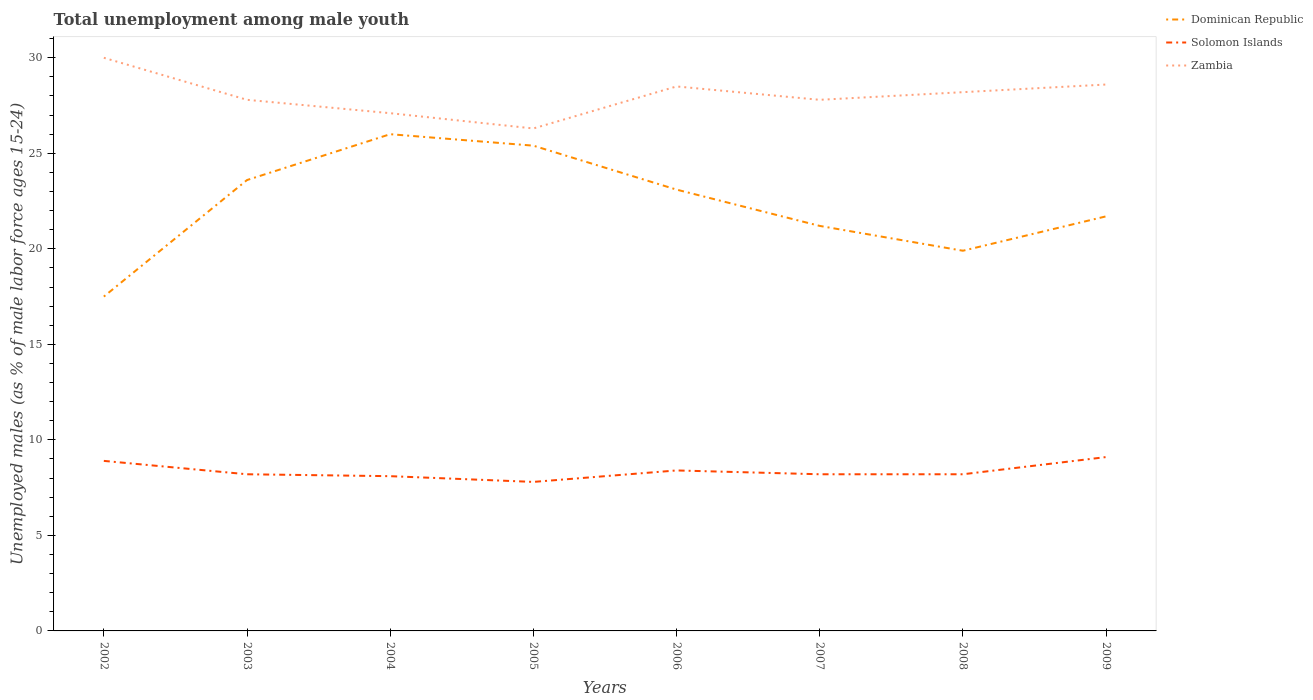How many different coloured lines are there?
Provide a short and direct response. 3. Does the line corresponding to Zambia intersect with the line corresponding to Solomon Islands?
Your answer should be very brief. No. Is the number of lines equal to the number of legend labels?
Give a very brief answer. Yes. Across all years, what is the maximum percentage of unemployed males in in Solomon Islands?
Give a very brief answer. 7.8. In which year was the percentage of unemployed males in in Zambia maximum?
Give a very brief answer. 2005. What is the total percentage of unemployed males in in Solomon Islands in the graph?
Make the answer very short. -0.4. What is the difference between the highest and the second highest percentage of unemployed males in in Dominican Republic?
Your answer should be very brief. 8.5. What is the difference between the highest and the lowest percentage of unemployed males in in Solomon Islands?
Provide a short and direct response. 3. How many lines are there?
Your response must be concise. 3. How many years are there in the graph?
Offer a terse response. 8. What is the difference between two consecutive major ticks on the Y-axis?
Your answer should be compact. 5. Are the values on the major ticks of Y-axis written in scientific E-notation?
Offer a terse response. No. Does the graph contain grids?
Give a very brief answer. No. What is the title of the graph?
Provide a short and direct response. Total unemployment among male youth. What is the label or title of the Y-axis?
Offer a terse response. Unemployed males (as % of male labor force ages 15-24). What is the Unemployed males (as % of male labor force ages 15-24) in Solomon Islands in 2002?
Your response must be concise. 8.9. What is the Unemployed males (as % of male labor force ages 15-24) of Zambia in 2002?
Offer a very short reply. 30. What is the Unemployed males (as % of male labor force ages 15-24) of Dominican Republic in 2003?
Make the answer very short. 23.6. What is the Unemployed males (as % of male labor force ages 15-24) of Solomon Islands in 2003?
Your response must be concise. 8.2. What is the Unemployed males (as % of male labor force ages 15-24) in Zambia in 2003?
Offer a very short reply. 27.8. What is the Unemployed males (as % of male labor force ages 15-24) of Dominican Republic in 2004?
Provide a succinct answer. 26. What is the Unemployed males (as % of male labor force ages 15-24) in Solomon Islands in 2004?
Your response must be concise. 8.1. What is the Unemployed males (as % of male labor force ages 15-24) in Zambia in 2004?
Give a very brief answer. 27.1. What is the Unemployed males (as % of male labor force ages 15-24) of Dominican Republic in 2005?
Ensure brevity in your answer.  25.4. What is the Unemployed males (as % of male labor force ages 15-24) of Solomon Islands in 2005?
Your answer should be very brief. 7.8. What is the Unemployed males (as % of male labor force ages 15-24) of Zambia in 2005?
Ensure brevity in your answer.  26.3. What is the Unemployed males (as % of male labor force ages 15-24) in Dominican Republic in 2006?
Provide a short and direct response. 23.1. What is the Unemployed males (as % of male labor force ages 15-24) in Solomon Islands in 2006?
Your answer should be very brief. 8.4. What is the Unemployed males (as % of male labor force ages 15-24) in Dominican Republic in 2007?
Give a very brief answer. 21.2. What is the Unemployed males (as % of male labor force ages 15-24) of Solomon Islands in 2007?
Your answer should be very brief. 8.2. What is the Unemployed males (as % of male labor force ages 15-24) of Zambia in 2007?
Keep it short and to the point. 27.8. What is the Unemployed males (as % of male labor force ages 15-24) of Dominican Republic in 2008?
Offer a very short reply. 19.9. What is the Unemployed males (as % of male labor force ages 15-24) in Solomon Islands in 2008?
Keep it short and to the point. 8.2. What is the Unemployed males (as % of male labor force ages 15-24) of Zambia in 2008?
Provide a short and direct response. 28.2. What is the Unemployed males (as % of male labor force ages 15-24) in Dominican Republic in 2009?
Your answer should be compact. 21.7. What is the Unemployed males (as % of male labor force ages 15-24) of Solomon Islands in 2009?
Offer a terse response. 9.1. What is the Unemployed males (as % of male labor force ages 15-24) of Zambia in 2009?
Keep it short and to the point. 28.6. Across all years, what is the maximum Unemployed males (as % of male labor force ages 15-24) of Dominican Republic?
Make the answer very short. 26. Across all years, what is the maximum Unemployed males (as % of male labor force ages 15-24) of Solomon Islands?
Offer a very short reply. 9.1. Across all years, what is the maximum Unemployed males (as % of male labor force ages 15-24) of Zambia?
Offer a very short reply. 30. Across all years, what is the minimum Unemployed males (as % of male labor force ages 15-24) in Dominican Republic?
Provide a short and direct response. 17.5. Across all years, what is the minimum Unemployed males (as % of male labor force ages 15-24) of Solomon Islands?
Your response must be concise. 7.8. Across all years, what is the minimum Unemployed males (as % of male labor force ages 15-24) of Zambia?
Your response must be concise. 26.3. What is the total Unemployed males (as % of male labor force ages 15-24) in Dominican Republic in the graph?
Provide a short and direct response. 178.4. What is the total Unemployed males (as % of male labor force ages 15-24) of Solomon Islands in the graph?
Your answer should be compact. 66.9. What is the total Unemployed males (as % of male labor force ages 15-24) in Zambia in the graph?
Give a very brief answer. 224.3. What is the difference between the Unemployed males (as % of male labor force ages 15-24) of Dominican Republic in 2002 and that in 2003?
Offer a terse response. -6.1. What is the difference between the Unemployed males (as % of male labor force ages 15-24) in Solomon Islands in 2002 and that in 2004?
Your answer should be compact. 0.8. What is the difference between the Unemployed males (as % of male labor force ages 15-24) in Zambia in 2002 and that in 2004?
Your answer should be compact. 2.9. What is the difference between the Unemployed males (as % of male labor force ages 15-24) in Dominican Republic in 2002 and that in 2005?
Keep it short and to the point. -7.9. What is the difference between the Unemployed males (as % of male labor force ages 15-24) of Dominican Republic in 2002 and that in 2006?
Provide a short and direct response. -5.6. What is the difference between the Unemployed males (as % of male labor force ages 15-24) of Zambia in 2002 and that in 2006?
Provide a short and direct response. 1.5. What is the difference between the Unemployed males (as % of male labor force ages 15-24) in Dominican Republic in 2002 and that in 2007?
Provide a short and direct response. -3.7. What is the difference between the Unemployed males (as % of male labor force ages 15-24) in Dominican Republic in 2002 and that in 2008?
Provide a succinct answer. -2.4. What is the difference between the Unemployed males (as % of male labor force ages 15-24) of Zambia in 2002 and that in 2008?
Make the answer very short. 1.8. What is the difference between the Unemployed males (as % of male labor force ages 15-24) of Dominican Republic in 2002 and that in 2009?
Your answer should be compact. -4.2. What is the difference between the Unemployed males (as % of male labor force ages 15-24) of Zambia in 2002 and that in 2009?
Your answer should be compact. 1.4. What is the difference between the Unemployed males (as % of male labor force ages 15-24) in Dominican Republic in 2003 and that in 2004?
Your answer should be compact. -2.4. What is the difference between the Unemployed males (as % of male labor force ages 15-24) of Solomon Islands in 2003 and that in 2004?
Offer a terse response. 0.1. What is the difference between the Unemployed males (as % of male labor force ages 15-24) of Zambia in 2003 and that in 2005?
Offer a terse response. 1.5. What is the difference between the Unemployed males (as % of male labor force ages 15-24) in Dominican Republic in 2003 and that in 2006?
Keep it short and to the point. 0.5. What is the difference between the Unemployed males (as % of male labor force ages 15-24) in Zambia in 2003 and that in 2006?
Provide a succinct answer. -0.7. What is the difference between the Unemployed males (as % of male labor force ages 15-24) of Solomon Islands in 2003 and that in 2007?
Provide a short and direct response. 0. What is the difference between the Unemployed males (as % of male labor force ages 15-24) in Solomon Islands in 2003 and that in 2008?
Your answer should be compact. 0. What is the difference between the Unemployed males (as % of male labor force ages 15-24) in Zambia in 2003 and that in 2009?
Keep it short and to the point. -0.8. What is the difference between the Unemployed males (as % of male labor force ages 15-24) in Solomon Islands in 2004 and that in 2005?
Offer a very short reply. 0.3. What is the difference between the Unemployed males (as % of male labor force ages 15-24) in Solomon Islands in 2004 and that in 2007?
Make the answer very short. -0.1. What is the difference between the Unemployed males (as % of male labor force ages 15-24) in Zambia in 2004 and that in 2007?
Offer a terse response. -0.7. What is the difference between the Unemployed males (as % of male labor force ages 15-24) in Zambia in 2004 and that in 2008?
Offer a very short reply. -1.1. What is the difference between the Unemployed males (as % of male labor force ages 15-24) of Solomon Islands in 2004 and that in 2009?
Keep it short and to the point. -1. What is the difference between the Unemployed males (as % of male labor force ages 15-24) in Dominican Republic in 2005 and that in 2006?
Give a very brief answer. 2.3. What is the difference between the Unemployed males (as % of male labor force ages 15-24) in Zambia in 2005 and that in 2006?
Offer a very short reply. -2.2. What is the difference between the Unemployed males (as % of male labor force ages 15-24) in Solomon Islands in 2005 and that in 2008?
Ensure brevity in your answer.  -0.4. What is the difference between the Unemployed males (as % of male labor force ages 15-24) in Zambia in 2005 and that in 2008?
Your answer should be compact. -1.9. What is the difference between the Unemployed males (as % of male labor force ages 15-24) in Dominican Republic in 2005 and that in 2009?
Your answer should be compact. 3.7. What is the difference between the Unemployed males (as % of male labor force ages 15-24) in Dominican Republic in 2006 and that in 2007?
Provide a succinct answer. 1.9. What is the difference between the Unemployed males (as % of male labor force ages 15-24) in Solomon Islands in 2006 and that in 2007?
Offer a terse response. 0.2. What is the difference between the Unemployed males (as % of male labor force ages 15-24) in Zambia in 2006 and that in 2007?
Provide a succinct answer. 0.7. What is the difference between the Unemployed males (as % of male labor force ages 15-24) of Solomon Islands in 2006 and that in 2008?
Your answer should be compact. 0.2. What is the difference between the Unemployed males (as % of male labor force ages 15-24) in Zambia in 2006 and that in 2009?
Your answer should be compact. -0.1. What is the difference between the Unemployed males (as % of male labor force ages 15-24) of Solomon Islands in 2007 and that in 2008?
Your answer should be very brief. 0. What is the difference between the Unemployed males (as % of male labor force ages 15-24) in Dominican Republic in 2008 and that in 2009?
Provide a short and direct response. -1.8. What is the difference between the Unemployed males (as % of male labor force ages 15-24) of Zambia in 2008 and that in 2009?
Keep it short and to the point. -0.4. What is the difference between the Unemployed males (as % of male labor force ages 15-24) of Dominican Republic in 2002 and the Unemployed males (as % of male labor force ages 15-24) of Zambia in 2003?
Ensure brevity in your answer.  -10.3. What is the difference between the Unemployed males (as % of male labor force ages 15-24) in Solomon Islands in 2002 and the Unemployed males (as % of male labor force ages 15-24) in Zambia in 2003?
Offer a very short reply. -18.9. What is the difference between the Unemployed males (as % of male labor force ages 15-24) of Solomon Islands in 2002 and the Unemployed males (as % of male labor force ages 15-24) of Zambia in 2004?
Your answer should be very brief. -18.2. What is the difference between the Unemployed males (as % of male labor force ages 15-24) of Dominican Republic in 2002 and the Unemployed males (as % of male labor force ages 15-24) of Zambia in 2005?
Provide a succinct answer. -8.8. What is the difference between the Unemployed males (as % of male labor force ages 15-24) in Solomon Islands in 2002 and the Unemployed males (as % of male labor force ages 15-24) in Zambia in 2005?
Offer a very short reply. -17.4. What is the difference between the Unemployed males (as % of male labor force ages 15-24) of Dominican Republic in 2002 and the Unemployed males (as % of male labor force ages 15-24) of Zambia in 2006?
Your answer should be compact. -11. What is the difference between the Unemployed males (as % of male labor force ages 15-24) of Solomon Islands in 2002 and the Unemployed males (as % of male labor force ages 15-24) of Zambia in 2006?
Provide a short and direct response. -19.6. What is the difference between the Unemployed males (as % of male labor force ages 15-24) of Dominican Republic in 2002 and the Unemployed males (as % of male labor force ages 15-24) of Zambia in 2007?
Give a very brief answer. -10.3. What is the difference between the Unemployed males (as % of male labor force ages 15-24) in Solomon Islands in 2002 and the Unemployed males (as % of male labor force ages 15-24) in Zambia in 2007?
Your answer should be very brief. -18.9. What is the difference between the Unemployed males (as % of male labor force ages 15-24) of Dominican Republic in 2002 and the Unemployed males (as % of male labor force ages 15-24) of Solomon Islands in 2008?
Offer a very short reply. 9.3. What is the difference between the Unemployed males (as % of male labor force ages 15-24) of Dominican Republic in 2002 and the Unemployed males (as % of male labor force ages 15-24) of Zambia in 2008?
Your answer should be very brief. -10.7. What is the difference between the Unemployed males (as % of male labor force ages 15-24) in Solomon Islands in 2002 and the Unemployed males (as % of male labor force ages 15-24) in Zambia in 2008?
Provide a short and direct response. -19.3. What is the difference between the Unemployed males (as % of male labor force ages 15-24) of Dominican Republic in 2002 and the Unemployed males (as % of male labor force ages 15-24) of Solomon Islands in 2009?
Make the answer very short. 8.4. What is the difference between the Unemployed males (as % of male labor force ages 15-24) of Dominican Republic in 2002 and the Unemployed males (as % of male labor force ages 15-24) of Zambia in 2009?
Ensure brevity in your answer.  -11.1. What is the difference between the Unemployed males (as % of male labor force ages 15-24) of Solomon Islands in 2002 and the Unemployed males (as % of male labor force ages 15-24) of Zambia in 2009?
Make the answer very short. -19.7. What is the difference between the Unemployed males (as % of male labor force ages 15-24) of Dominican Republic in 2003 and the Unemployed males (as % of male labor force ages 15-24) of Zambia in 2004?
Make the answer very short. -3.5. What is the difference between the Unemployed males (as % of male labor force ages 15-24) of Solomon Islands in 2003 and the Unemployed males (as % of male labor force ages 15-24) of Zambia in 2004?
Keep it short and to the point. -18.9. What is the difference between the Unemployed males (as % of male labor force ages 15-24) of Solomon Islands in 2003 and the Unemployed males (as % of male labor force ages 15-24) of Zambia in 2005?
Make the answer very short. -18.1. What is the difference between the Unemployed males (as % of male labor force ages 15-24) in Solomon Islands in 2003 and the Unemployed males (as % of male labor force ages 15-24) in Zambia in 2006?
Give a very brief answer. -20.3. What is the difference between the Unemployed males (as % of male labor force ages 15-24) in Dominican Republic in 2003 and the Unemployed males (as % of male labor force ages 15-24) in Zambia in 2007?
Make the answer very short. -4.2. What is the difference between the Unemployed males (as % of male labor force ages 15-24) of Solomon Islands in 2003 and the Unemployed males (as % of male labor force ages 15-24) of Zambia in 2007?
Offer a terse response. -19.6. What is the difference between the Unemployed males (as % of male labor force ages 15-24) in Solomon Islands in 2003 and the Unemployed males (as % of male labor force ages 15-24) in Zambia in 2008?
Make the answer very short. -20. What is the difference between the Unemployed males (as % of male labor force ages 15-24) of Solomon Islands in 2003 and the Unemployed males (as % of male labor force ages 15-24) of Zambia in 2009?
Your response must be concise. -20.4. What is the difference between the Unemployed males (as % of male labor force ages 15-24) of Solomon Islands in 2004 and the Unemployed males (as % of male labor force ages 15-24) of Zambia in 2005?
Your answer should be compact. -18.2. What is the difference between the Unemployed males (as % of male labor force ages 15-24) of Dominican Republic in 2004 and the Unemployed males (as % of male labor force ages 15-24) of Solomon Islands in 2006?
Keep it short and to the point. 17.6. What is the difference between the Unemployed males (as % of male labor force ages 15-24) in Dominican Republic in 2004 and the Unemployed males (as % of male labor force ages 15-24) in Zambia in 2006?
Give a very brief answer. -2.5. What is the difference between the Unemployed males (as % of male labor force ages 15-24) in Solomon Islands in 2004 and the Unemployed males (as % of male labor force ages 15-24) in Zambia in 2006?
Your response must be concise. -20.4. What is the difference between the Unemployed males (as % of male labor force ages 15-24) in Dominican Republic in 2004 and the Unemployed males (as % of male labor force ages 15-24) in Solomon Islands in 2007?
Your answer should be compact. 17.8. What is the difference between the Unemployed males (as % of male labor force ages 15-24) in Solomon Islands in 2004 and the Unemployed males (as % of male labor force ages 15-24) in Zambia in 2007?
Offer a very short reply. -19.7. What is the difference between the Unemployed males (as % of male labor force ages 15-24) in Solomon Islands in 2004 and the Unemployed males (as % of male labor force ages 15-24) in Zambia in 2008?
Your answer should be very brief. -20.1. What is the difference between the Unemployed males (as % of male labor force ages 15-24) in Dominican Republic in 2004 and the Unemployed males (as % of male labor force ages 15-24) in Zambia in 2009?
Give a very brief answer. -2.6. What is the difference between the Unemployed males (as % of male labor force ages 15-24) of Solomon Islands in 2004 and the Unemployed males (as % of male labor force ages 15-24) of Zambia in 2009?
Offer a terse response. -20.5. What is the difference between the Unemployed males (as % of male labor force ages 15-24) in Dominican Republic in 2005 and the Unemployed males (as % of male labor force ages 15-24) in Zambia in 2006?
Your response must be concise. -3.1. What is the difference between the Unemployed males (as % of male labor force ages 15-24) of Solomon Islands in 2005 and the Unemployed males (as % of male labor force ages 15-24) of Zambia in 2006?
Your answer should be very brief. -20.7. What is the difference between the Unemployed males (as % of male labor force ages 15-24) of Dominican Republic in 2005 and the Unemployed males (as % of male labor force ages 15-24) of Solomon Islands in 2007?
Ensure brevity in your answer.  17.2. What is the difference between the Unemployed males (as % of male labor force ages 15-24) in Dominican Republic in 2005 and the Unemployed males (as % of male labor force ages 15-24) in Zambia in 2007?
Ensure brevity in your answer.  -2.4. What is the difference between the Unemployed males (as % of male labor force ages 15-24) in Dominican Republic in 2005 and the Unemployed males (as % of male labor force ages 15-24) in Solomon Islands in 2008?
Provide a succinct answer. 17.2. What is the difference between the Unemployed males (as % of male labor force ages 15-24) in Dominican Republic in 2005 and the Unemployed males (as % of male labor force ages 15-24) in Zambia in 2008?
Give a very brief answer. -2.8. What is the difference between the Unemployed males (as % of male labor force ages 15-24) of Solomon Islands in 2005 and the Unemployed males (as % of male labor force ages 15-24) of Zambia in 2008?
Give a very brief answer. -20.4. What is the difference between the Unemployed males (as % of male labor force ages 15-24) in Dominican Republic in 2005 and the Unemployed males (as % of male labor force ages 15-24) in Zambia in 2009?
Give a very brief answer. -3.2. What is the difference between the Unemployed males (as % of male labor force ages 15-24) of Solomon Islands in 2005 and the Unemployed males (as % of male labor force ages 15-24) of Zambia in 2009?
Ensure brevity in your answer.  -20.8. What is the difference between the Unemployed males (as % of male labor force ages 15-24) of Dominican Republic in 2006 and the Unemployed males (as % of male labor force ages 15-24) of Zambia in 2007?
Provide a succinct answer. -4.7. What is the difference between the Unemployed males (as % of male labor force ages 15-24) in Solomon Islands in 2006 and the Unemployed males (as % of male labor force ages 15-24) in Zambia in 2007?
Your answer should be compact. -19.4. What is the difference between the Unemployed males (as % of male labor force ages 15-24) in Dominican Republic in 2006 and the Unemployed males (as % of male labor force ages 15-24) in Zambia in 2008?
Your answer should be compact. -5.1. What is the difference between the Unemployed males (as % of male labor force ages 15-24) in Solomon Islands in 2006 and the Unemployed males (as % of male labor force ages 15-24) in Zambia in 2008?
Give a very brief answer. -19.8. What is the difference between the Unemployed males (as % of male labor force ages 15-24) in Solomon Islands in 2006 and the Unemployed males (as % of male labor force ages 15-24) in Zambia in 2009?
Your response must be concise. -20.2. What is the difference between the Unemployed males (as % of male labor force ages 15-24) of Dominican Republic in 2007 and the Unemployed males (as % of male labor force ages 15-24) of Zambia in 2008?
Make the answer very short. -7. What is the difference between the Unemployed males (as % of male labor force ages 15-24) in Solomon Islands in 2007 and the Unemployed males (as % of male labor force ages 15-24) in Zambia in 2009?
Offer a terse response. -20.4. What is the difference between the Unemployed males (as % of male labor force ages 15-24) in Solomon Islands in 2008 and the Unemployed males (as % of male labor force ages 15-24) in Zambia in 2009?
Provide a succinct answer. -20.4. What is the average Unemployed males (as % of male labor force ages 15-24) in Dominican Republic per year?
Your answer should be compact. 22.3. What is the average Unemployed males (as % of male labor force ages 15-24) in Solomon Islands per year?
Ensure brevity in your answer.  8.36. What is the average Unemployed males (as % of male labor force ages 15-24) in Zambia per year?
Give a very brief answer. 28.04. In the year 2002, what is the difference between the Unemployed males (as % of male labor force ages 15-24) of Dominican Republic and Unemployed males (as % of male labor force ages 15-24) of Solomon Islands?
Offer a very short reply. 8.6. In the year 2002, what is the difference between the Unemployed males (as % of male labor force ages 15-24) of Solomon Islands and Unemployed males (as % of male labor force ages 15-24) of Zambia?
Keep it short and to the point. -21.1. In the year 2003, what is the difference between the Unemployed males (as % of male labor force ages 15-24) of Dominican Republic and Unemployed males (as % of male labor force ages 15-24) of Solomon Islands?
Provide a short and direct response. 15.4. In the year 2003, what is the difference between the Unemployed males (as % of male labor force ages 15-24) of Dominican Republic and Unemployed males (as % of male labor force ages 15-24) of Zambia?
Ensure brevity in your answer.  -4.2. In the year 2003, what is the difference between the Unemployed males (as % of male labor force ages 15-24) in Solomon Islands and Unemployed males (as % of male labor force ages 15-24) in Zambia?
Offer a terse response. -19.6. In the year 2004, what is the difference between the Unemployed males (as % of male labor force ages 15-24) in Dominican Republic and Unemployed males (as % of male labor force ages 15-24) in Solomon Islands?
Provide a succinct answer. 17.9. In the year 2005, what is the difference between the Unemployed males (as % of male labor force ages 15-24) of Dominican Republic and Unemployed males (as % of male labor force ages 15-24) of Solomon Islands?
Provide a short and direct response. 17.6. In the year 2005, what is the difference between the Unemployed males (as % of male labor force ages 15-24) of Solomon Islands and Unemployed males (as % of male labor force ages 15-24) of Zambia?
Make the answer very short. -18.5. In the year 2006, what is the difference between the Unemployed males (as % of male labor force ages 15-24) in Dominican Republic and Unemployed males (as % of male labor force ages 15-24) in Solomon Islands?
Your answer should be compact. 14.7. In the year 2006, what is the difference between the Unemployed males (as % of male labor force ages 15-24) in Dominican Republic and Unemployed males (as % of male labor force ages 15-24) in Zambia?
Ensure brevity in your answer.  -5.4. In the year 2006, what is the difference between the Unemployed males (as % of male labor force ages 15-24) of Solomon Islands and Unemployed males (as % of male labor force ages 15-24) of Zambia?
Give a very brief answer. -20.1. In the year 2007, what is the difference between the Unemployed males (as % of male labor force ages 15-24) of Dominican Republic and Unemployed males (as % of male labor force ages 15-24) of Zambia?
Your answer should be compact. -6.6. In the year 2007, what is the difference between the Unemployed males (as % of male labor force ages 15-24) in Solomon Islands and Unemployed males (as % of male labor force ages 15-24) in Zambia?
Your response must be concise. -19.6. In the year 2008, what is the difference between the Unemployed males (as % of male labor force ages 15-24) of Dominican Republic and Unemployed males (as % of male labor force ages 15-24) of Zambia?
Your answer should be very brief. -8.3. In the year 2009, what is the difference between the Unemployed males (as % of male labor force ages 15-24) of Dominican Republic and Unemployed males (as % of male labor force ages 15-24) of Zambia?
Give a very brief answer. -6.9. In the year 2009, what is the difference between the Unemployed males (as % of male labor force ages 15-24) of Solomon Islands and Unemployed males (as % of male labor force ages 15-24) of Zambia?
Provide a short and direct response. -19.5. What is the ratio of the Unemployed males (as % of male labor force ages 15-24) in Dominican Republic in 2002 to that in 2003?
Keep it short and to the point. 0.74. What is the ratio of the Unemployed males (as % of male labor force ages 15-24) of Solomon Islands in 2002 to that in 2003?
Your answer should be compact. 1.09. What is the ratio of the Unemployed males (as % of male labor force ages 15-24) of Zambia in 2002 to that in 2003?
Keep it short and to the point. 1.08. What is the ratio of the Unemployed males (as % of male labor force ages 15-24) in Dominican Republic in 2002 to that in 2004?
Provide a short and direct response. 0.67. What is the ratio of the Unemployed males (as % of male labor force ages 15-24) of Solomon Islands in 2002 to that in 2004?
Your answer should be compact. 1.1. What is the ratio of the Unemployed males (as % of male labor force ages 15-24) in Zambia in 2002 to that in 2004?
Give a very brief answer. 1.11. What is the ratio of the Unemployed males (as % of male labor force ages 15-24) in Dominican Republic in 2002 to that in 2005?
Your answer should be compact. 0.69. What is the ratio of the Unemployed males (as % of male labor force ages 15-24) of Solomon Islands in 2002 to that in 2005?
Ensure brevity in your answer.  1.14. What is the ratio of the Unemployed males (as % of male labor force ages 15-24) of Zambia in 2002 to that in 2005?
Keep it short and to the point. 1.14. What is the ratio of the Unemployed males (as % of male labor force ages 15-24) of Dominican Republic in 2002 to that in 2006?
Give a very brief answer. 0.76. What is the ratio of the Unemployed males (as % of male labor force ages 15-24) in Solomon Islands in 2002 to that in 2006?
Your answer should be compact. 1.06. What is the ratio of the Unemployed males (as % of male labor force ages 15-24) in Zambia in 2002 to that in 2006?
Offer a very short reply. 1.05. What is the ratio of the Unemployed males (as % of male labor force ages 15-24) of Dominican Republic in 2002 to that in 2007?
Give a very brief answer. 0.83. What is the ratio of the Unemployed males (as % of male labor force ages 15-24) of Solomon Islands in 2002 to that in 2007?
Make the answer very short. 1.09. What is the ratio of the Unemployed males (as % of male labor force ages 15-24) of Zambia in 2002 to that in 2007?
Your response must be concise. 1.08. What is the ratio of the Unemployed males (as % of male labor force ages 15-24) in Dominican Republic in 2002 to that in 2008?
Ensure brevity in your answer.  0.88. What is the ratio of the Unemployed males (as % of male labor force ages 15-24) in Solomon Islands in 2002 to that in 2008?
Your answer should be compact. 1.09. What is the ratio of the Unemployed males (as % of male labor force ages 15-24) in Zambia in 2002 to that in 2008?
Make the answer very short. 1.06. What is the ratio of the Unemployed males (as % of male labor force ages 15-24) in Dominican Republic in 2002 to that in 2009?
Offer a very short reply. 0.81. What is the ratio of the Unemployed males (as % of male labor force ages 15-24) in Zambia in 2002 to that in 2009?
Offer a very short reply. 1.05. What is the ratio of the Unemployed males (as % of male labor force ages 15-24) of Dominican Republic in 2003 to that in 2004?
Make the answer very short. 0.91. What is the ratio of the Unemployed males (as % of male labor force ages 15-24) of Solomon Islands in 2003 to that in 2004?
Give a very brief answer. 1.01. What is the ratio of the Unemployed males (as % of male labor force ages 15-24) of Zambia in 2003 to that in 2004?
Keep it short and to the point. 1.03. What is the ratio of the Unemployed males (as % of male labor force ages 15-24) in Dominican Republic in 2003 to that in 2005?
Your answer should be very brief. 0.93. What is the ratio of the Unemployed males (as % of male labor force ages 15-24) in Solomon Islands in 2003 to that in 2005?
Your response must be concise. 1.05. What is the ratio of the Unemployed males (as % of male labor force ages 15-24) in Zambia in 2003 to that in 2005?
Keep it short and to the point. 1.06. What is the ratio of the Unemployed males (as % of male labor force ages 15-24) in Dominican Republic in 2003 to that in 2006?
Make the answer very short. 1.02. What is the ratio of the Unemployed males (as % of male labor force ages 15-24) of Solomon Islands in 2003 to that in 2006?
Provide a short and direct response. 0.98. What is the ratio of the Unemployed males (as % of male labor force ages 15-24) of Zambia in 2003 to that in 2006?
Give a very brief answer. 0.98. What is the ratio of the Unemployed males (as % of male labor force ages 15-24) in Dominican Republic in 2003 to that in 2007?
Make the answer very short. 1.11. What is the ratio of the Unemployed males (as % of male labor force ages 15-24) of Zambia in 2003 to that in 2007?
Your answer should be very brief. 1. What is the ratio of the Unemployed males (as % of male labor force ages 15-24) of Dominican Republic in 2003 to that in 2008?
Offer a very short reply. 1.19. What is the ratio of the Unemployed males (as % of male labor force ages 15-24) of Solomon Islands in 2003 to that in 2008?
Your answer should be very brief. 1. What is the ratio of the Unemployed males (as % of male labor force ages 15-24) in Zambia in 2003 to that in 2008?
Offer a very short reply. 0.99. What is the ratio of the Unemployed males (as % of male labor force ages 15-24) of Dominican Republic in 2003 to that in 2009?
Your response must be concise. 1.09. What is the ratio of the Unemployed males (as % of male labor force ages 15-24) in Solomon Islands in 2003 to that in 2009?
Give a very brief answer. 0.9. What is the ratio of the Unemployed males (as % of male labor force ages 15-24) in Zambia in 2003 to that in 2009?
Provide a succinct answer. 0.97. What is the ratio of the Unemployed males (as % of male labor force ages 15-24) of Dominican Republic in 2004 to that in 2005?
Give a very brief answer. 1.02. What is the ratio of the Unemployed males (as % of male labor force ages 15-24) of Zambia in 2004 to that in 2005?
Provide a short and direct response. 1.03. What is the ratio of the Unemployed males (as % of male labor force ages 15-24) of Dominican Republic in 2004 to that in 2006?
Your response must be concise. 1.13. What is the ratio of the Unemployed males (as % of male labor force ages 15-24) of Zambia in 2004 to that in 2006?
Make the answer very short. 0.95. What is the ratio of the Unemployed males (as % of male labor force ages 15-24) in Dominican Republic in 2004 to that in 2007?
Provide a succinct answer. 1.23. What is the ratio of the Unemployed males (as % of male labor force ages 15-24) in Zambia in 2004 to that in 2007?
Keep it short and to the point. 0.97. What is the ratio of the Unemployed males (as % of male labor force ages 15-24) in Dominican Republic in 2004 to that in 2008?
Ensure brevity in your answer.  1.31. What is the ratio of the Unemployed males (as % of male labor force ages 15-24) of Solomon Islands in 2004 to that in 2008?
Ensure brevity in your answer.  0.99. What is the ratio of the Unemployed males (as % of male labor force ages 15-24) of Zambia in 2004 to that in 2008?
Provide a succinct answer. 0.96. What is the ratio of the Unemployed males (as % of male labor force ages 15-24) of Dominican Republic in 2004 to that in 2009?
Provide a succinct answer. 1.2. What is the ratio of the Unemployed males (as % of male labor force ages 15-24) in Solomon Islands in 2004 to that in 2009?
Offer a terse response. 0.89. What is the ratio of the Unemployed males (as % of male labor force ages 15-24) of Zambia in 2004 to that in 2009?
Offer a terse response. 0.95. What is the ratio of the Unemployed males (as % of male labor force ages 15-24) in Dominican Republic in 2005 to that in 2006?
Your answer should be compact. 1.1. What is the ratio of the Unemployed males (as % of male labor force ages 15-24) of Zambia in 2005 to that in 2006?
Your response must be concise. 0.92. What is the ratio of the Unemployed males (as % of male labor force ages 15-24) in Dominican Republic in 2005 to that in 2007?
Offer a terse response. 1.2. What is the ratio of the Unemployed males (as % of male labor force ages 15-24) in Solomon Islands in 2005 to that in 2007?
Keep it short and to the point. 0.95. What is the ratio of the Unemployed males (as % of male labor force ages 15-24) of Zambia in 2005 to that in 2007?
Give a very brief answer. 0.95. What is the ratio of the Unemployed males (as % of male labor force ages 15-24) in Dominican Republic in 2005 to that in 2008?
Offer a very short reply. 1.28. What is the ratio of the Unemployed males (as % of male labor force ages 15-24) in Solomon Islands in 2005 to that in 2008?
Give a very brief answer. 0.95. What is the ratio of the Unemployed males (as % of male labor force ages 15-24) in Zambia in 2005 to that in 2008?
Ensure brevity in your answer.  0.93. What is the ratio of the Unemployed males (as % of male labor force ages 15-24) in Dominican Republic in 2005 to that in 2009?
Keep it short and to the point. 1.17. What is the ratio of the Unemployed males (as % of male labor force ages 15-24) in Solomon Islands in 2005 to that in 2009?
Give a very brief answer. 0.86. What is the ratio of the Unemployed males (as % of male labor force ages 15-24) in Zambia in 2005 to that in 2009?
Offer a terse response. 0.92. What is the ratio of the Unemployed males (as % of male labor force ages 15-24) in Dominican Republic in 2006 to that in 2007?
Provide a succinct answer. 1.09. What is the ratio of the Unemployed males (as % of male labor force ages 15-24) in Solomon Islands in 2006 to that in 2007?
Provide a succinct answer. 1.02. What is the ratio of the Unemployed males (as % of male labor force ages 15-24) in Zambia in 2006 to that in 2007?
Provide a succinct answer. 1.03. What is the ratio of the Unemployed males (as % of male labor force ages 15-24) in Dominican Republic in 2006 to that in 2008?
Offer a terse response. 1.16. What is the ratio of the Unemployed males (as % of male labor force ages 15-24) in Solomon Islands in 2006 to that in 2008?
Your answer should be very brief. 1.02. What is the ratio of the Unemployed males (as % of male labor force ages 15-24) of Zambia in 2006 to that in 2008?
Keep it short and to the point. 1.01. What is the ratio of the Unemployed males (as % of male labor force ages 15-24) of Dominican Republic in 2006 to that in 2009?
Provide a succinct answer. 1.06. What is the ratio of the Unemployed males (as % of male labor force ages 15-24) in Solomon Islands in 2006 to that in 2009?
Make the answer very short. 0.92. What is the ratio of the Unemployed males (as % of male labor force ages 15-24) in Dominican Republic in 2007 to that in 2008?
Your answer should be very brief. 1.07. What is the ratio of the Unemployed males (as % of male labor force ages 15-24) of Zambia in 2007 to that in 2008?
Ensure brevity in your answer.  0.99. What is the ratio of the Unemployed males (as % of male labor force ages 15-24) of Solomon Islands in 2007 to that in 2009?
Provide a short and direct response. 0.9. What is the ratio of the Unemployed males (as % of male labor force ages 15-24) in Dominican Republic in 2008 to that in 2009?
Give a very brief answer. 0.92. What is the ratio of the Unemployed males (as % of male labor force ages 15-24) in Solomon Islands in 2008 to that in 2009?
Make the answer very short. 0.9. What is the ratio of the Unemployed males (as % of male labor force ages 15-24) of Zambia in 2008 to that in 2009?
Keep it short and to the point. 0.99. What is the difference between the highest and the second highest Unemployed males (as % of male labor force ages 15-24) in Zambia?
Offer a very short reply. 1.4. What is the difference between the highest and the lowest Unemployed males (as % of male labor force ages 15-24) in Solomon Islands?
Provide a succinct answer. 1.3. What is the difference between the highest and the lowest Unemployed males (as % of male labor force ages 15-24) of Zambia?
Your answer should be compact. 3.7. 